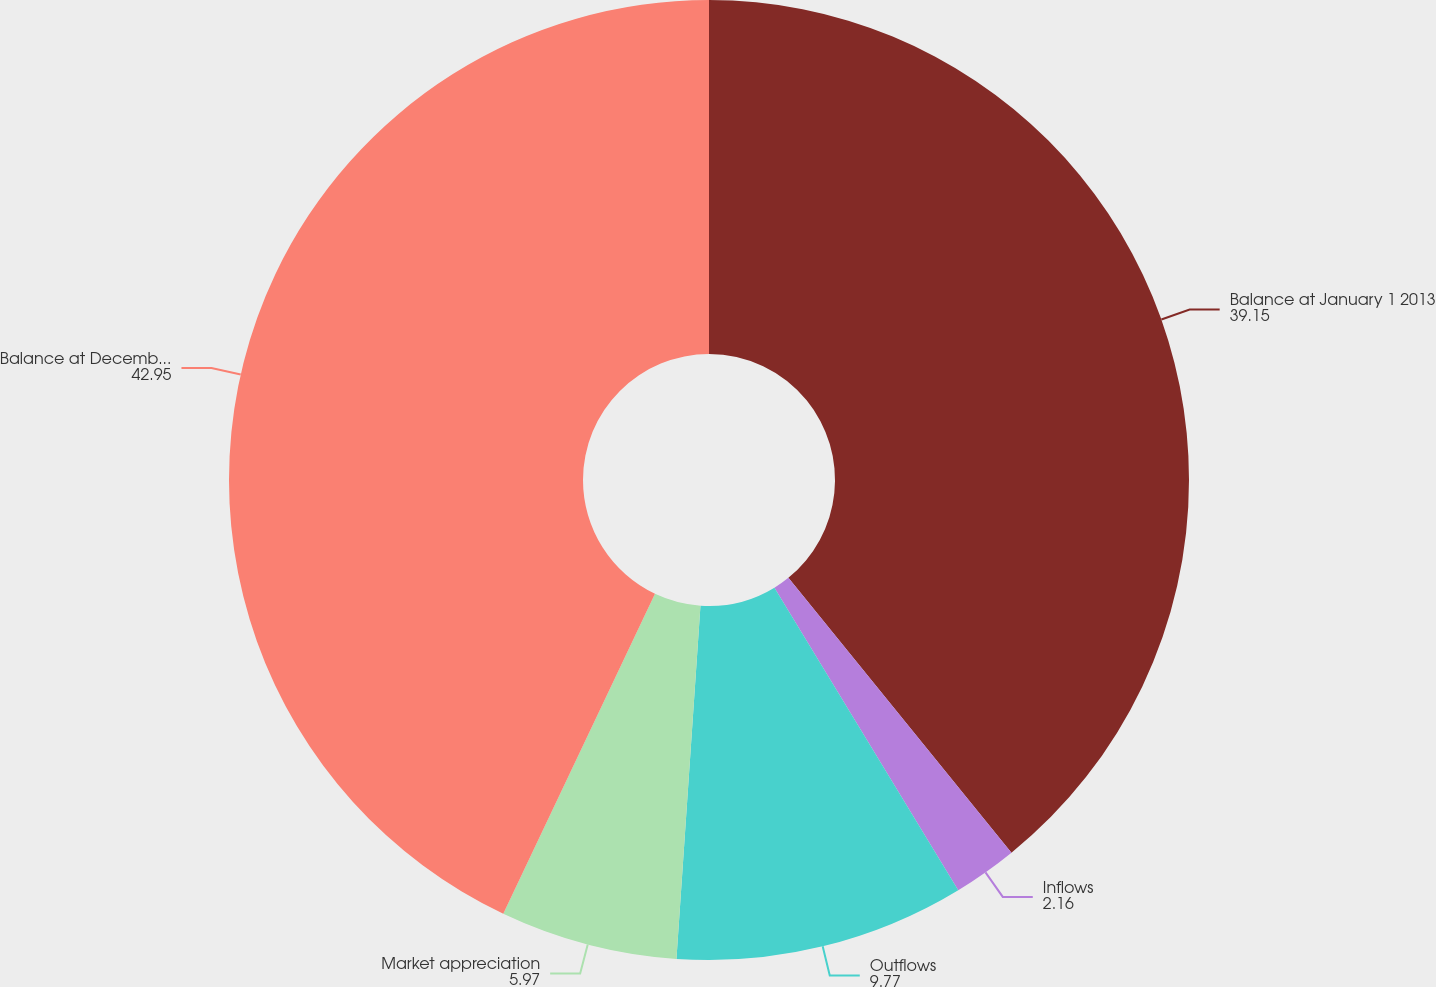Convert chart. <chart><loc_0><loc_0><loc_500><loc_500><pie_chart><fcel>Balance at January 1 2013<fcel>Inflows<fcel>Outflows<fcel>Market appreciation<fcel>Balance at December 31 2013<nl><fcel>39.15%<fcel>2.16%<fcel>9.77%<fcel>5.97%<fcel>42.95%<nl></chart> 